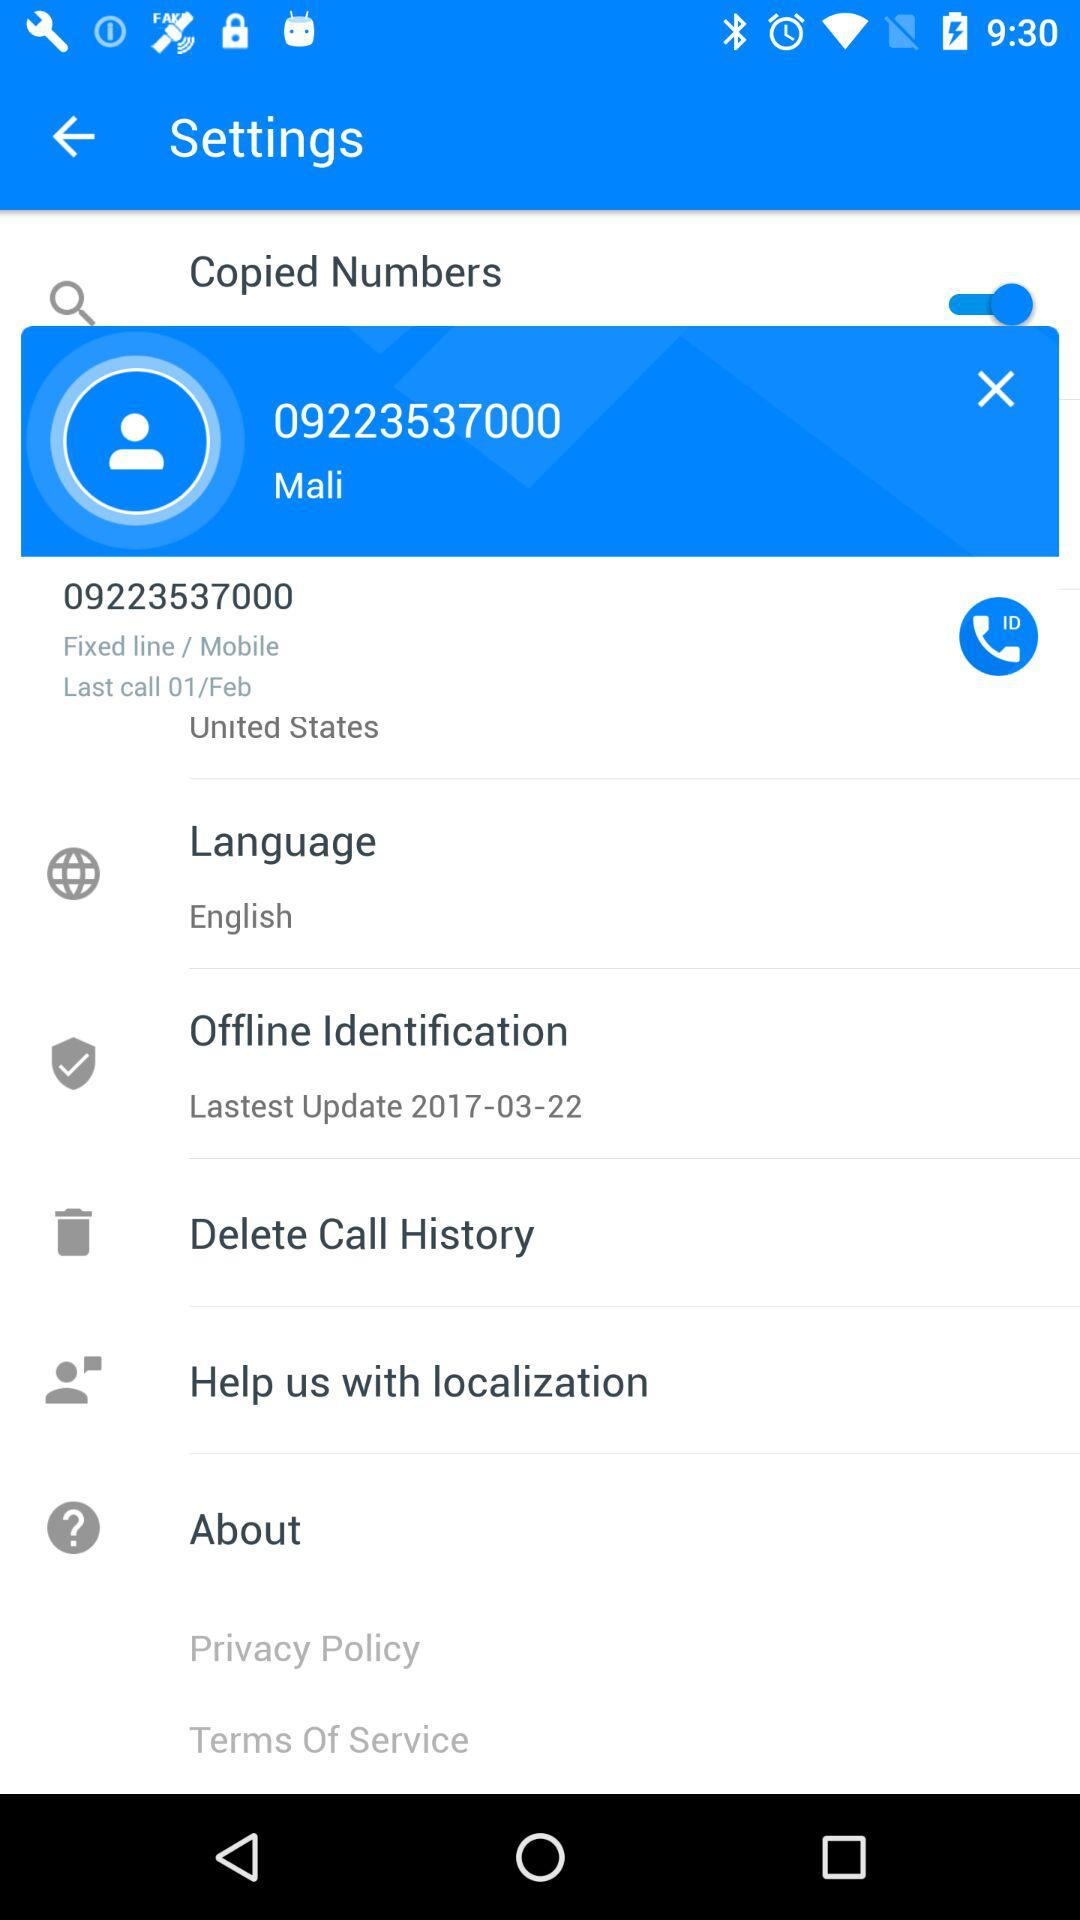What is the location of the phone number? The location is the United States. 